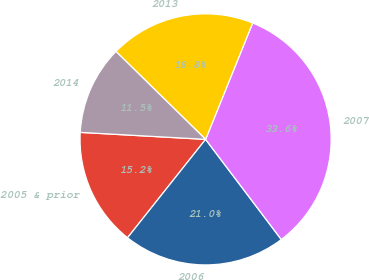Convert chart. <chart><loc_0><loc_0><loc_500><loc_500><pie_chart><fcel>2005 & prior<fcel>2006<fcel>2007<fcel>2013<fcel>2014<nl><fcel>15.21%<fcel>20.98%<fcel>33.58%<fcel>18.77%<fcel>11.46%<nl></chart> 